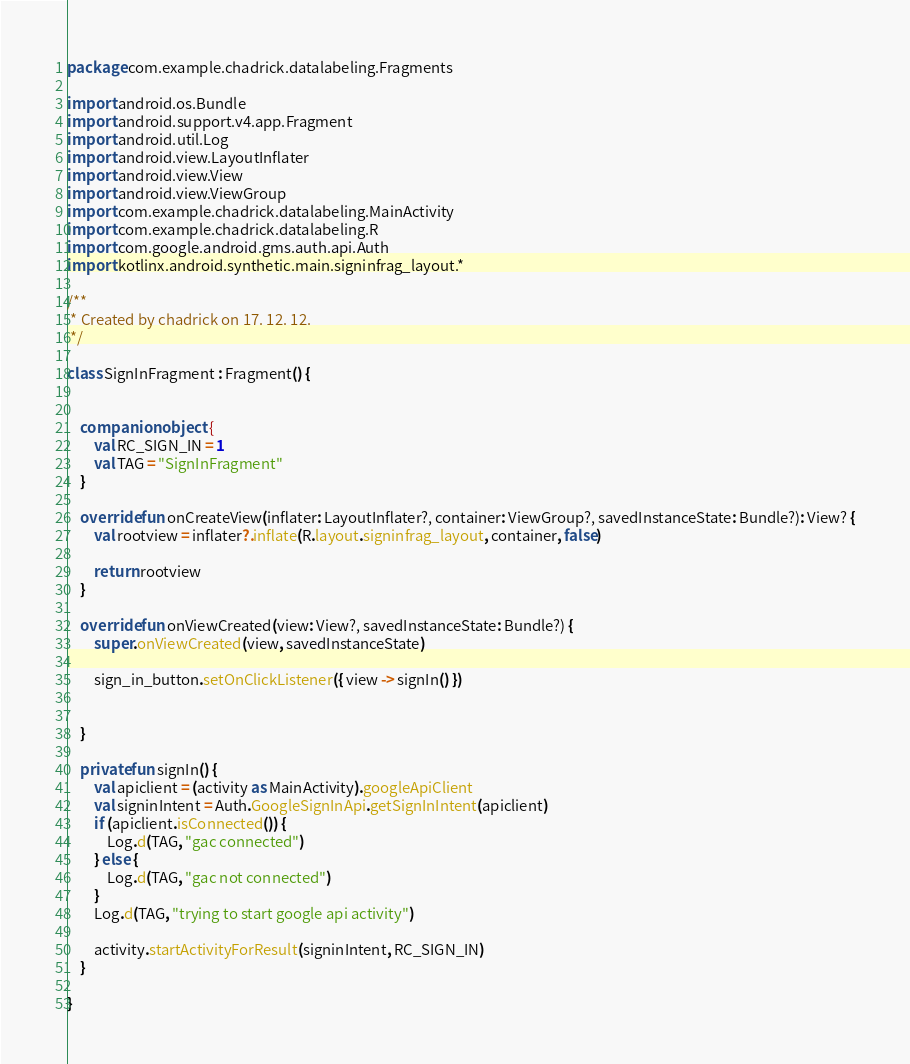<code> <loc_0><loc_0><loc_500><loc_500><_Kotlin_>package com.example.chadrick.datalabeling.Fragments

import android.os.Bundle
import android.support.v4.app.Fragment
import android.util.Log
import android.view.LayoutInflater
import android.view.View
import android.view.ViewGroup
import com.example.chadrick.datalabeling.MainActivity
import com.example.chadrick.datalabeling.R
import com.google.android.gms.auth.api.Auth
import kotlinx.android.synthetic.main.signinfrag_layout.*

/**
 * Created by chadrick on 17. 12. 12.
 */

class SignInFragment : Fragment() {


    companion object {
        val RC_SIGN_IN = 1
        val TAG = "SignInFragment"
    }

    override fun onCreateView(inflater: LayoutInflater?, container: ViewGroup?, savedInstanceState: Bundle?): View? {
        val rootview = inflater?.inflate(R.layout.signinfrag_layout, container, false)

        return rootview
    }

    override fun onViewCreated(view: View?, savedInstanceState: Bundle?) {
        super.onViewCreated(view, savedInstanceState)

        sign_in_button.setOnClickListener({ view -> signIn() })


    }

    private fun signIn() {
        val apiclient = (activity as MainActivity).googleApiClient
        val signinIntent = Auth.GoogleSignInApi.getSignInIntent(apiclient)
        if (apiclient.isConnected()) {
            Log.d(TAG, "gac connected")
        } else {
            Log.d(TAG, "gac not connected")
        }
        Log.d(TAG, "trying to start google api activity")

        activity.startActivityForResult(signinIntent, RC_SIGN_IN)
    }

}</code> 